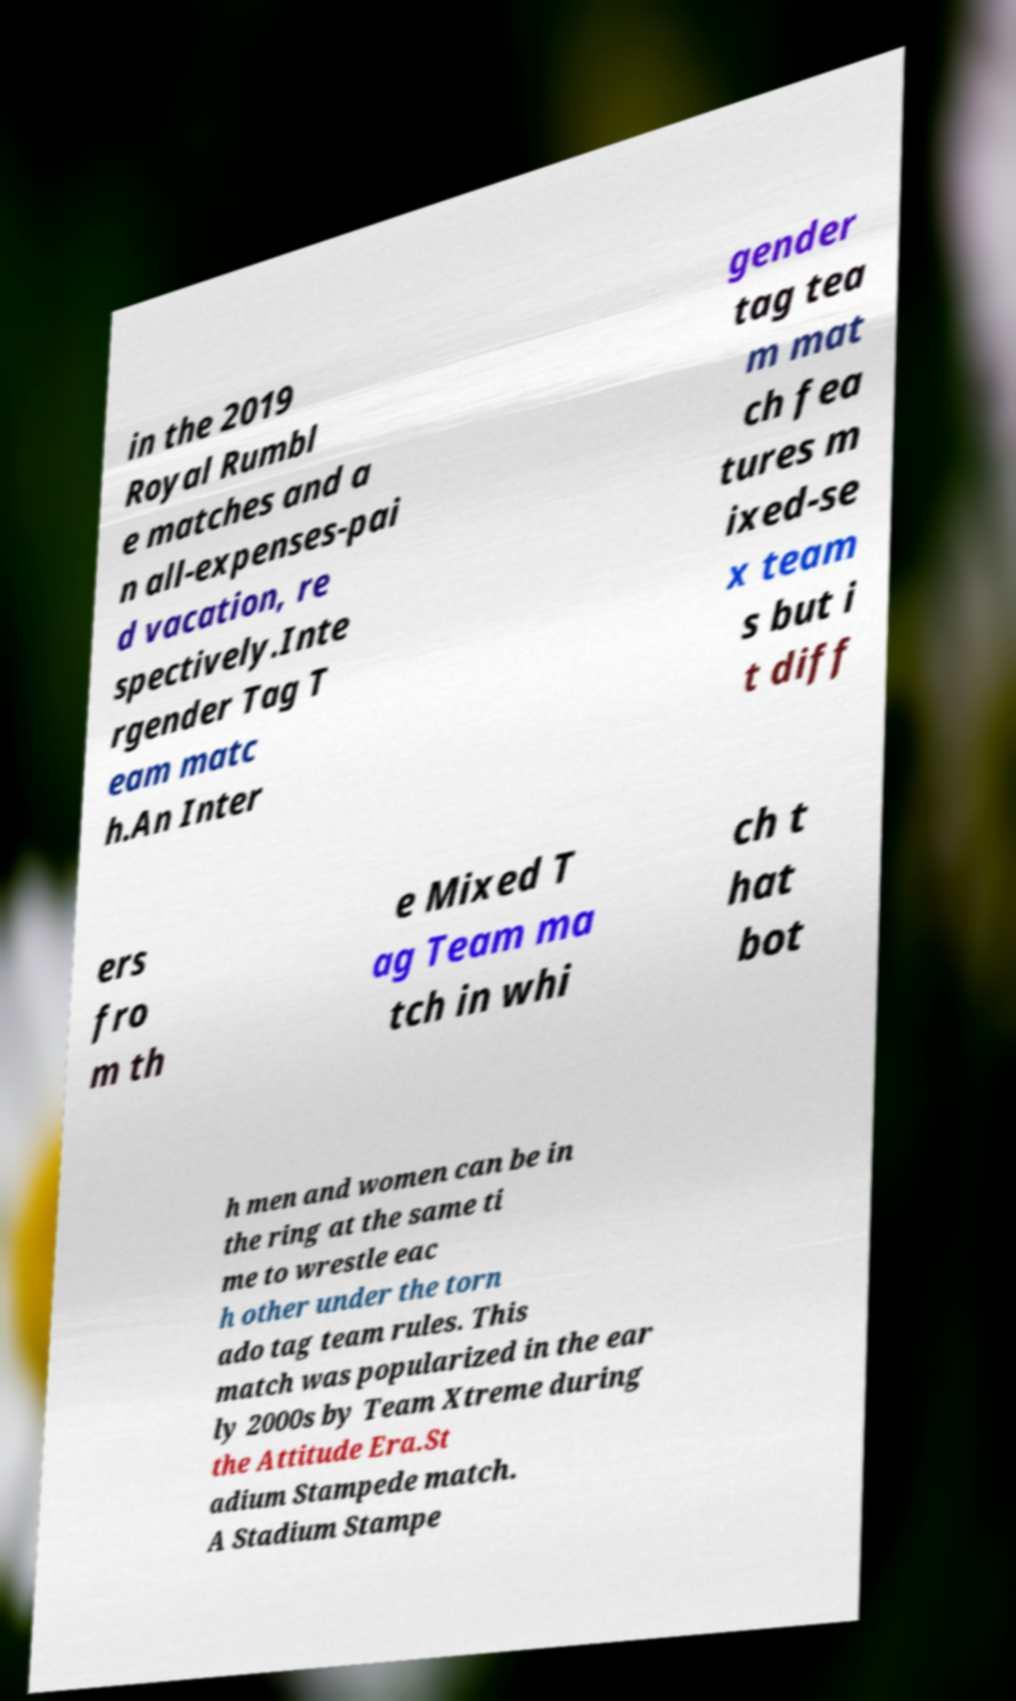I need the written content from this picture converted into text. Can you do that? in the 2019 Royal Rumbl e matches and a n all-expenses-pai d vacation, re spectively.Inte rgender Tag T eam matc h.An Inter gender tag tea m mat ch fea tures m ixed-se x team s but i t diff ers fro m th e Mixed T ag Team ma tch in whi ch t hat bot h men and women can be in the ring at the same ti me to wrestle eac h other under the torn ado tag team rules. This match was popularized in the ear ly 2000s by Team Xtreme during the Attitude Era.St adium Stampede match. A Stadium Stampe 